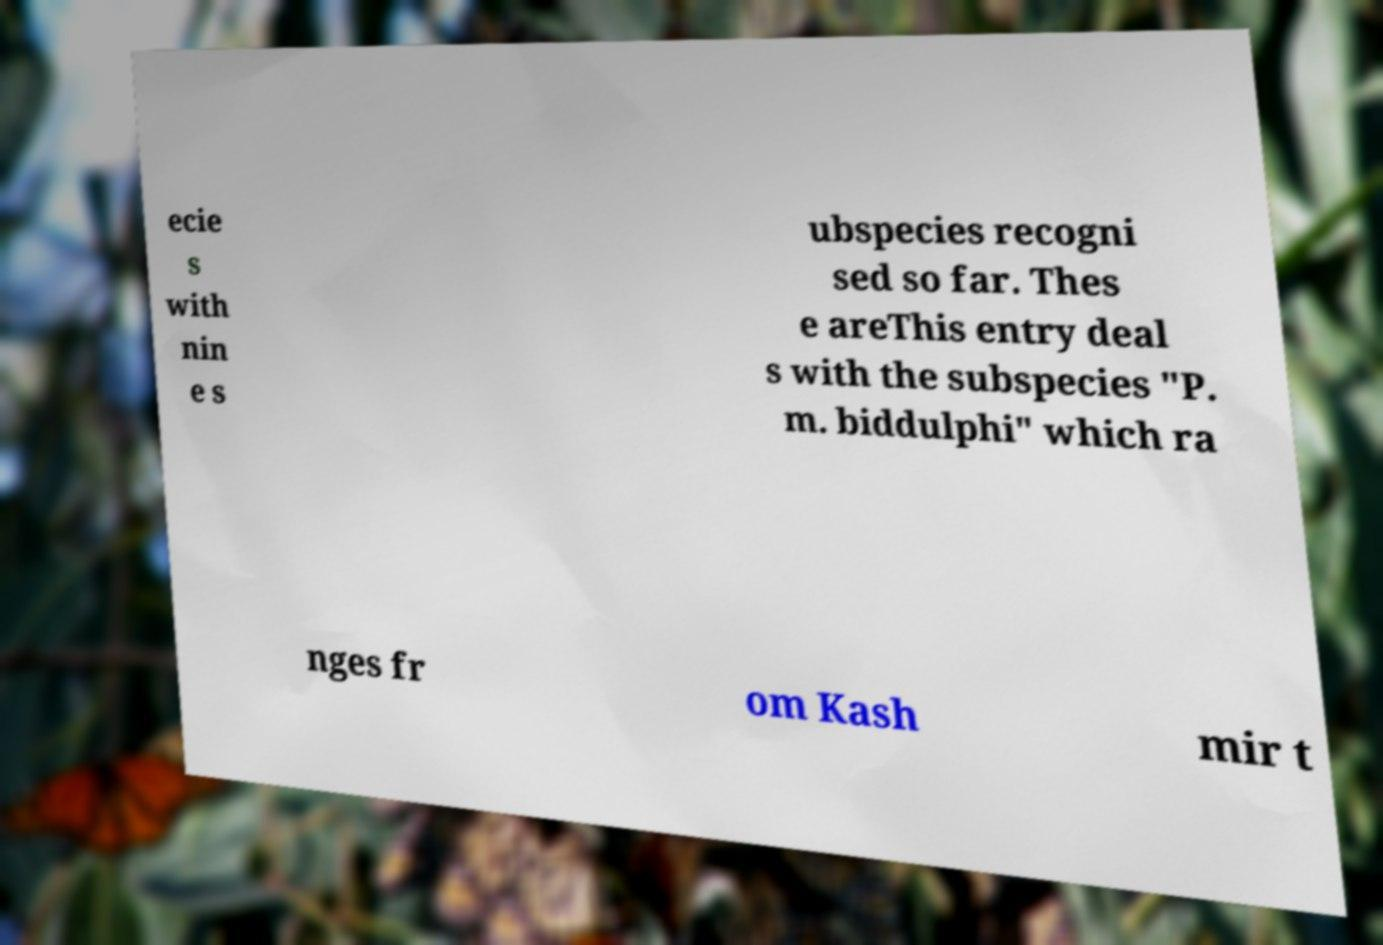Please read and relay the text visible in this image. What does it say? ecie s with nin e s ubspecies recogni sed so far. Thes e areThis entry deal s with the subspecies "P. m. biddulphi" which ra nges fr om Kash mir t 